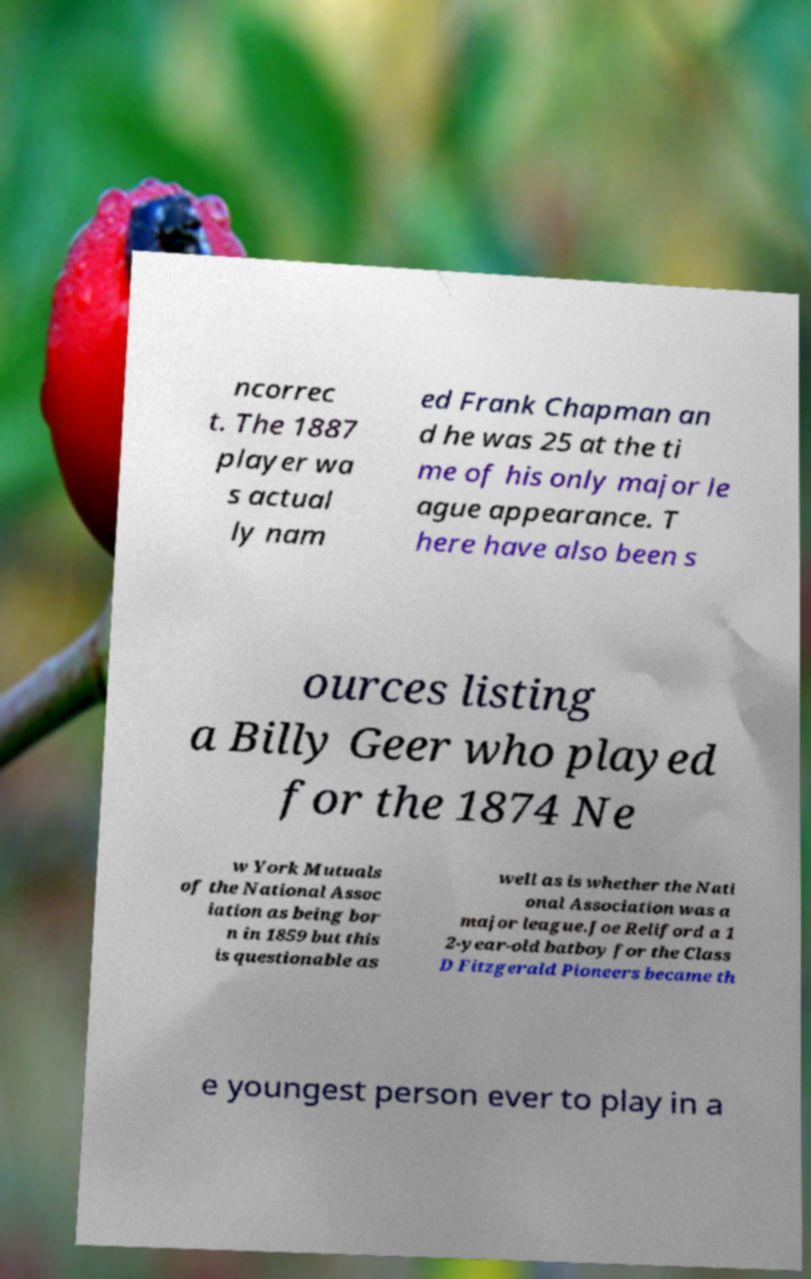For documentation purposes, I need the text within this image transcribed. Could you provide that? ncorrec t. The 1887 player wa s actual ly nam ed Frank Chapman an d he was 25 at the ti me of his only major le ague appearance. T here have also been s ources listing a Billy Geer who played for the 1874 Ne w York Mutuals of the National Assoc iation as being bor n in 1859 but this is questionable as well as is whether the Nati onal Association was a major league.Joe Reliford a 1 2-year-old batboy for the Class D Fitzgerald Pioneers became th e youngest person ever to play in a 